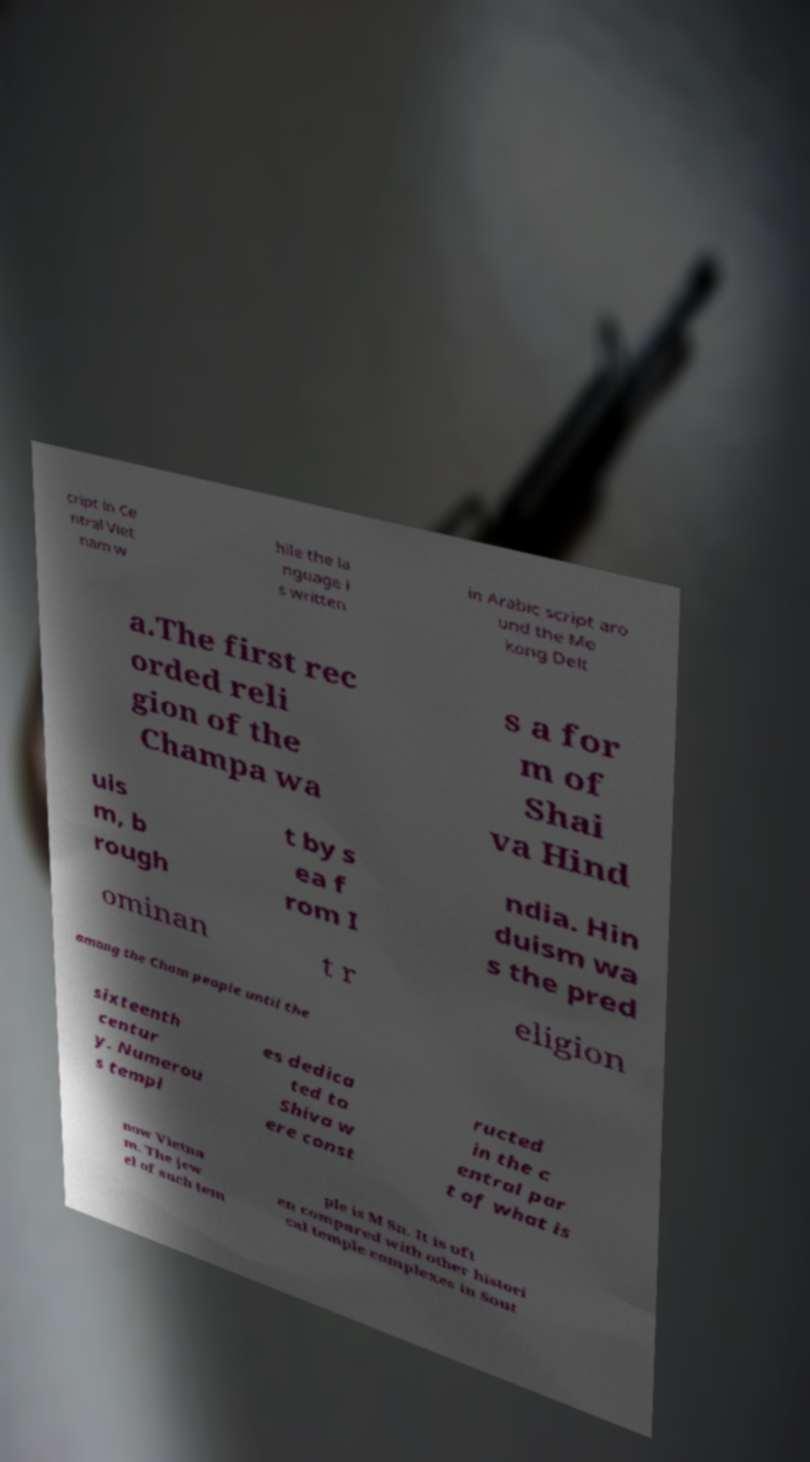Could you extract and type out the text from this image? cript in Ce ntral Viet nam w hile the la nguage i s written in Arabic script aro und the Me kong Delt a.The first rec orded reli gion of the Champa wa s a for m of Shai va Hind uis m, b rough t by s ea f rom I ndia. Hin duism wa s the pred ominan t r eligion among the Cham people until the sixteenth centur y. Numerou s templ es dedica ted to Shiva w ere const ructed in the c entral par t of what is now Vietna m. The jew el of such tem ple is M Sn. It is oft en compared with other histori cal temple complexes in Sout 